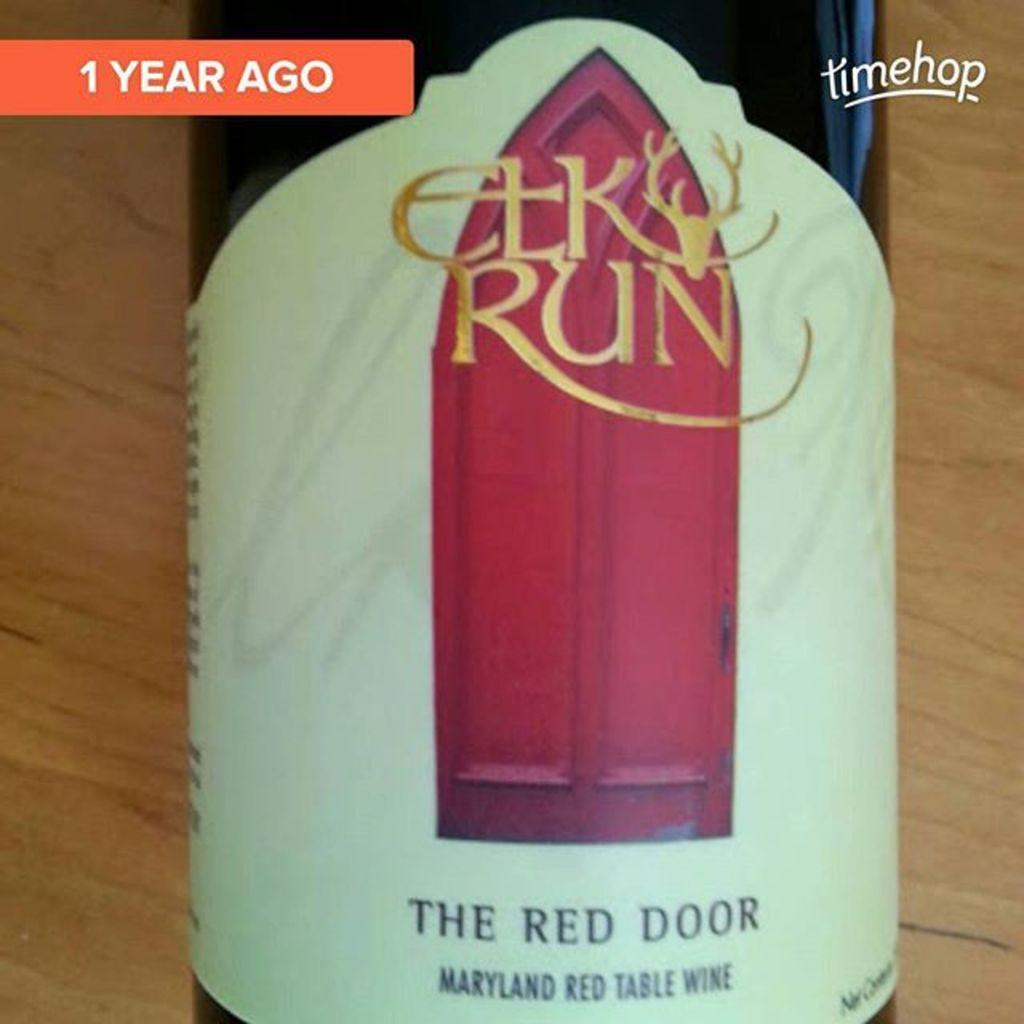<image>
Present a compact description of the photo's key features. A glass bottle of The Red Door Maryland wine 